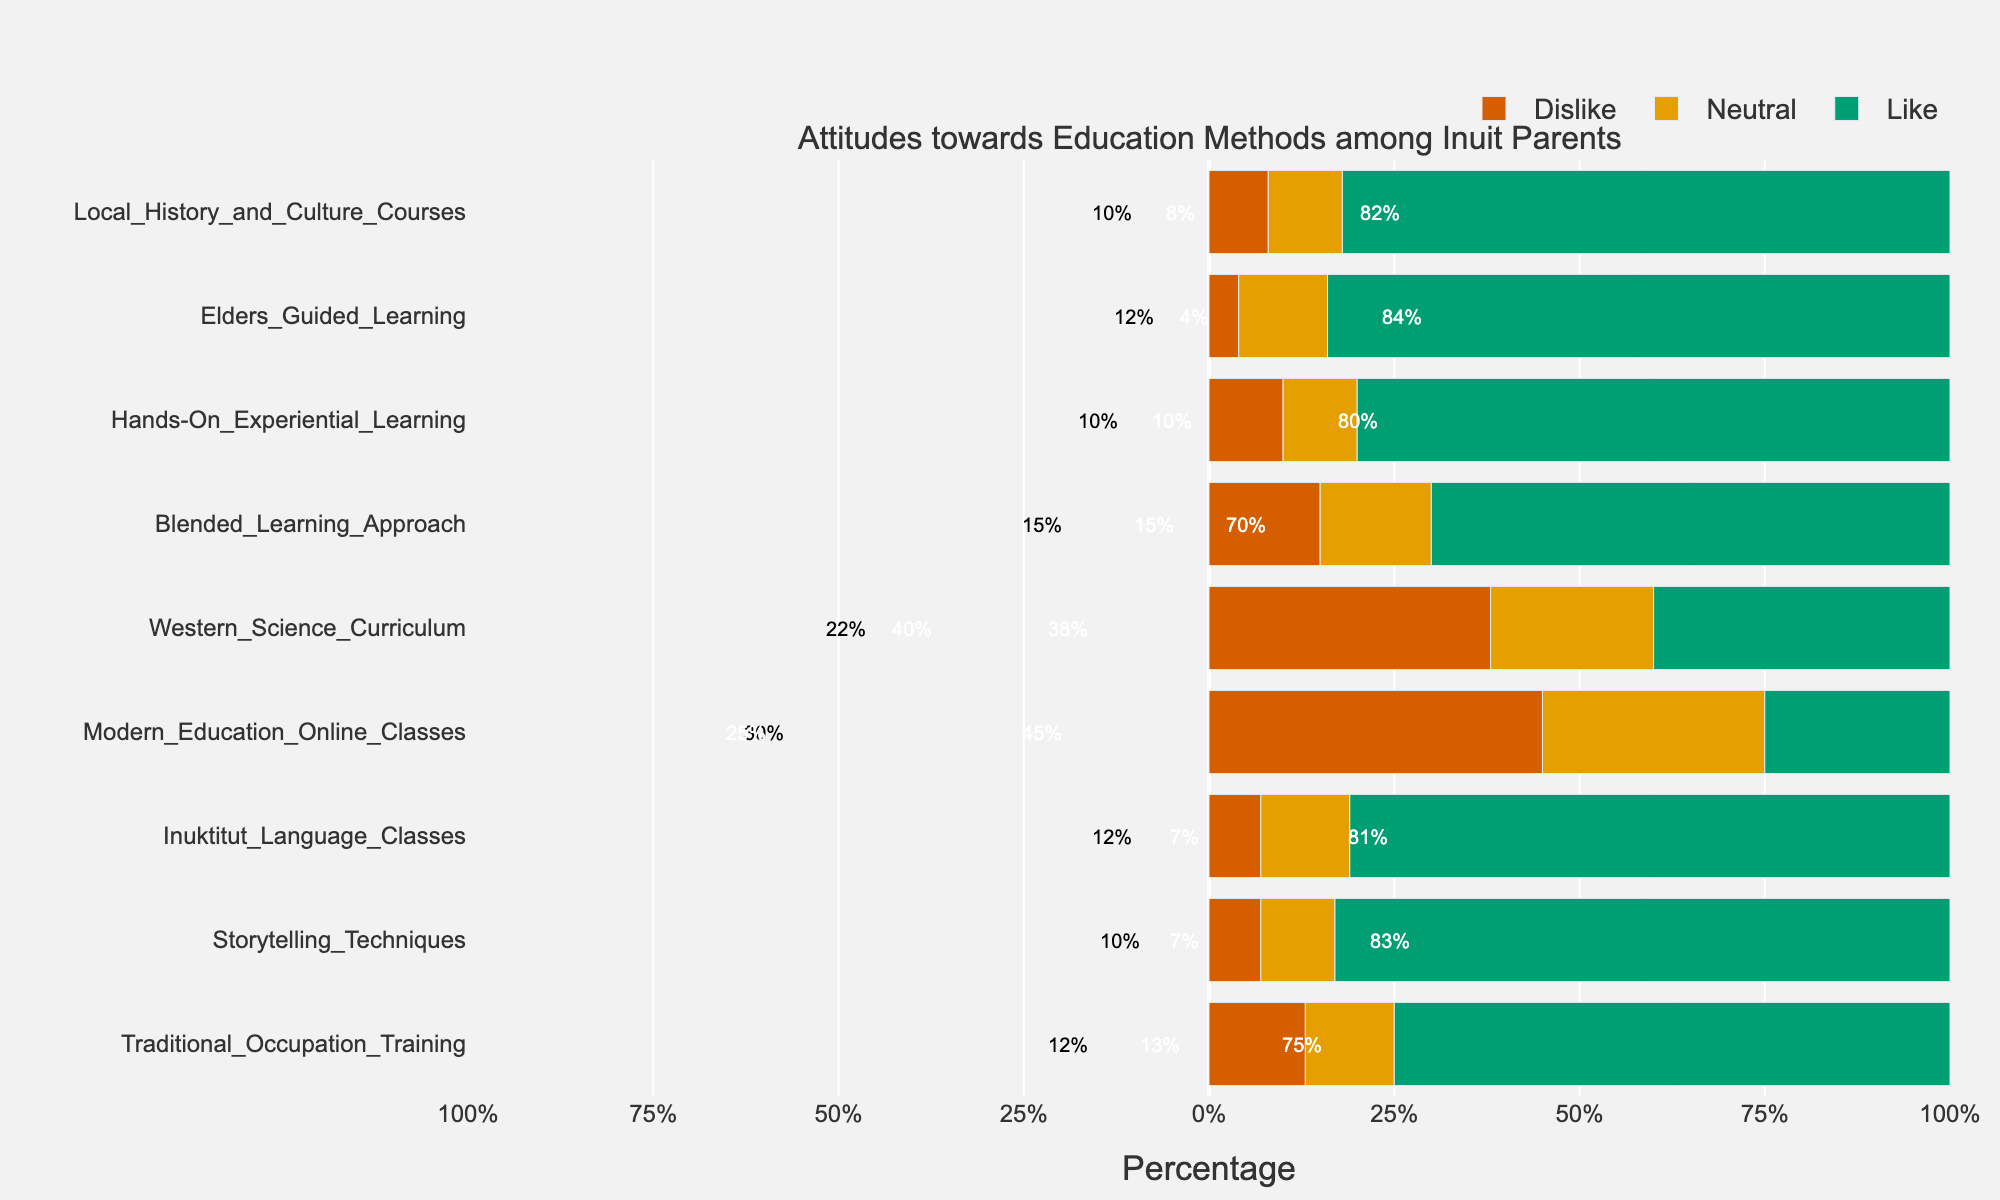Which education method has the highest percentage of 'Strongly Like' responses? Look for the bar that has the largest green segment on the positive side and check the corresponding education method.
Answer: Elders Guided Learning Which education method has the highest combined percentage of 'Like' and 'Strongly Like'? Combine the percentages of 'Like' and 'Strongly Like' segments for each education method and compare. Elders Guided Learning has 35% Like and 49% Strongly Like, which sum up to 84%.
Answer: Elders Guided Learning What is the total percentage of 'Dislike' and 'Strongly Dislike' for Modern Education Online Classes? Add the percentages of 'Dislike' and 'Strongly Dislike' for Modern Education Online Classes. 'Dislike' is 25% and 'Strongly Dislike' is 20%, so 25% + 20% = 45%.
Answer: 45% Which education methods have a negative response percentage of less than 10%? Identify the methods where the combined percentages of 'Dislike' and 'Strongly Dislike' are less than 10%. Inuktitut Language Classes (2+5=7%), Storytelling Techniques (3+4=7%), Hands-On Experiential Learning (4+6=10%), and Elders Guided Learning (1+3=4%).
Answer: Inuktitut Language Classes, Storytelling Techniques, Hands-On Experiential Learning, Elders Guided Learning How does the percentage of neutral responses for Western Science Curriculum compare to that for Blended Learning Approach? Compare the length of the neutral (orange) bars for Western Science Curriculum and Blended Learning Approach. Western Science Curriculum has 22% Neutral, and Blended Learning Approach has 15% Neutral.
Answer: Western Science Curriculum Which education method has the most evenly distributed response percentages? Identify the method where the percentages of 'Strongly Dislike', 'Dislike', 'Neutral', 'Like', and 'Strongly Like' are relatively close to each other. Modern Education Online Classes with 20% Strongly Dislike, 25% Dislike, 30% Neutral, 15% Like, and 10% Strongly Like.
Answer: Modern Education Online Classes Which education methods have positive response percentages ('Like' + 'Strongly Like') of 70% or more? Calculate the combined percentage of 'Like' and 'Strongly Like' for each method and find those with 70% or more. Storytelling Techniques has (40%+43%=83%), Inuktitut Language Classes has (38%+43%=81%), Hands-On Experiential Learning has (40%+40%=80%), Elders Guided Learning has (35%+49%=84%), Local History and Culture Courses has (35%+47%=82%).
Answer: Storytelling Techniques, Inuktitut Language Classes, Hands-On Experiential Learning, Elders Guided Learning, Local History and Culture Courses Which education method has the highest percentage of 'Neutral' responses? Look for the longest orange segment in the neutral responses and check the corresponding education method. Modern Education Online Classes (30%).
Answer: Modern Education Online Classes How does the percentage of 'Strongly Dislike' for Western Science Curriculum compare to that for Blended Learning Approach? Compare the red segments for the two methods. Western Science Curriculum has 18% 'Strongly Dislike', while Blended Learning Approach has 5% 'Strongly Dislike'.
Answer: Western Science Curriculum 